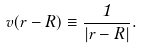<formula> <loc_0><loc_0><loc_500><loc_500>v ( r - R ) \equiv \frac { 1 } { | r - R | } .</formula> 